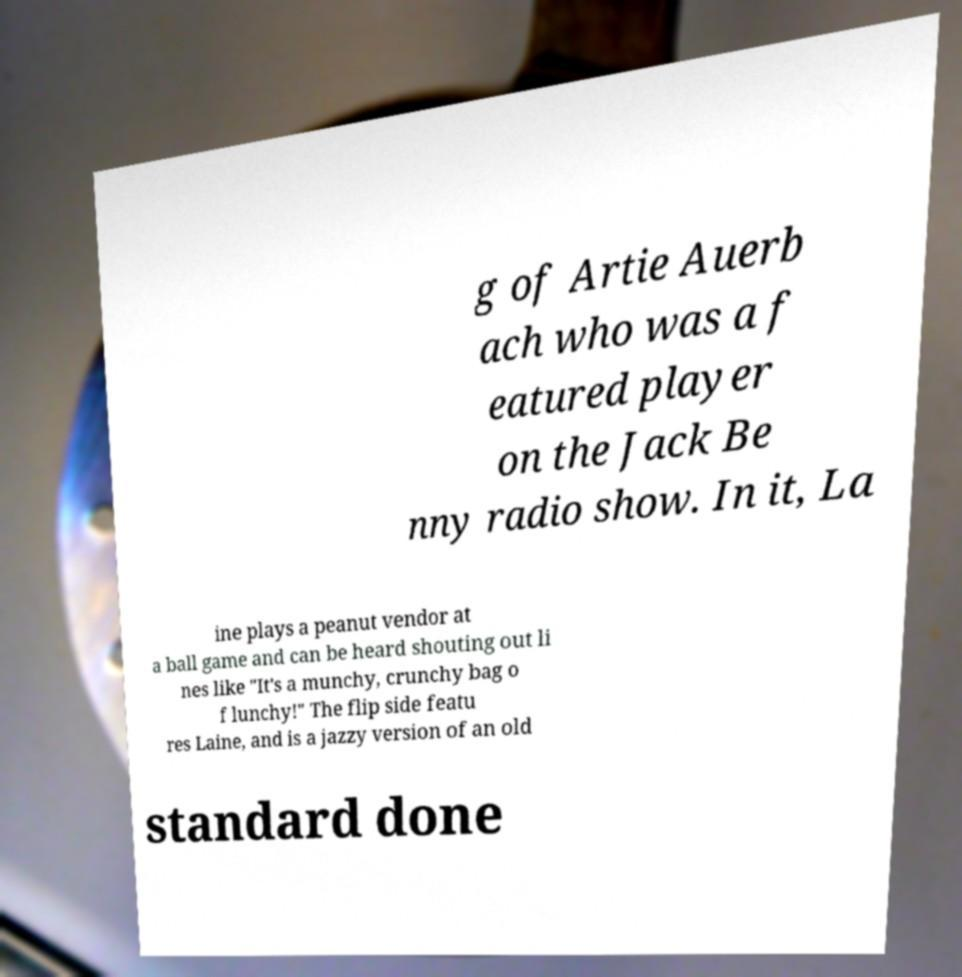Could you extract and type out the text from this image? g of Artie Auerb ach who was a f eatured player on the Jack Be nny radio show. In it, La ine plays a peanut vendor at a ball game and can be heard shouting out li nes like "It's a munchy, crunchy bag o f lunchy!" The flip side featu res Laine, and is a jazzy version of an old standard done 